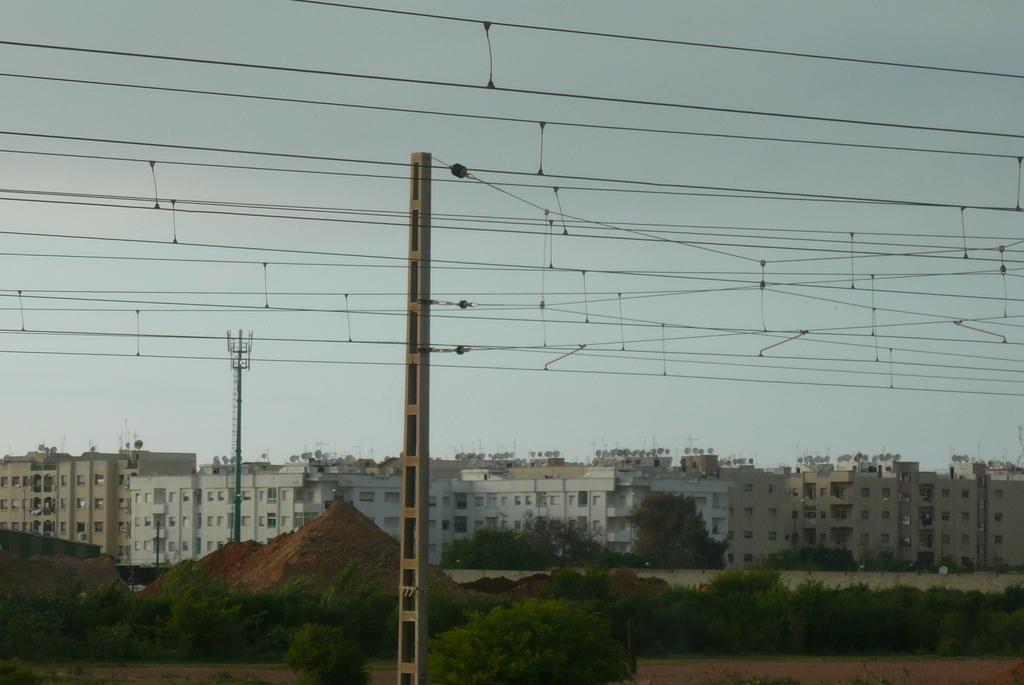Describe this image in one or two sentences. There is a pole. Also there are wires. In the back there are trees and a heap of soil. Also there is an electric pole. In the background there are buildings with windows. Also there is sky. 